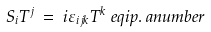Convert formula to latex. <formula><loc_0><loc_0><loc_500><loc_500>S _ { i } T ^ { j } & \ = \ i \varepsilon _ { i j k } T ^ { k } \ e q i p { . } \ a n u m b e r</formula> 